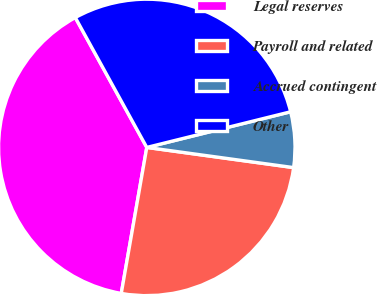Convert chart. <chart><loc_0><loc_0><loc_500><loc_500><pie_chart><fcel>Legal reserves<fcel>Payroll and related<fcel>Accrued contingent<fcel>Other<nl><fcel>39.24%<fcel>25.58%<fcel>6.04%<fcel>29.14%<nl></chart> 